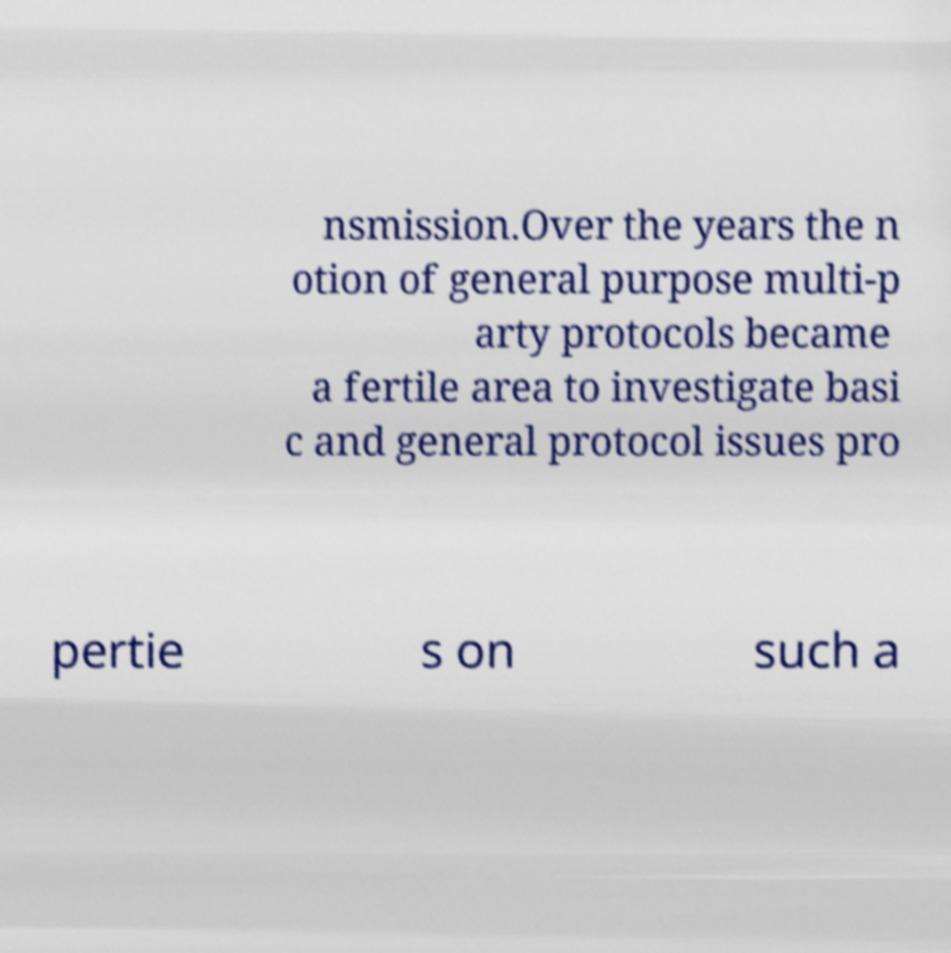For documentation purposes, I need the text within this image transcribed. Could you provide that? nsmission.Over the years the n otion of general purpose multi-p arty protocols became a fertile area to investigate basi c and general protocol issues pro pertie s on such a 